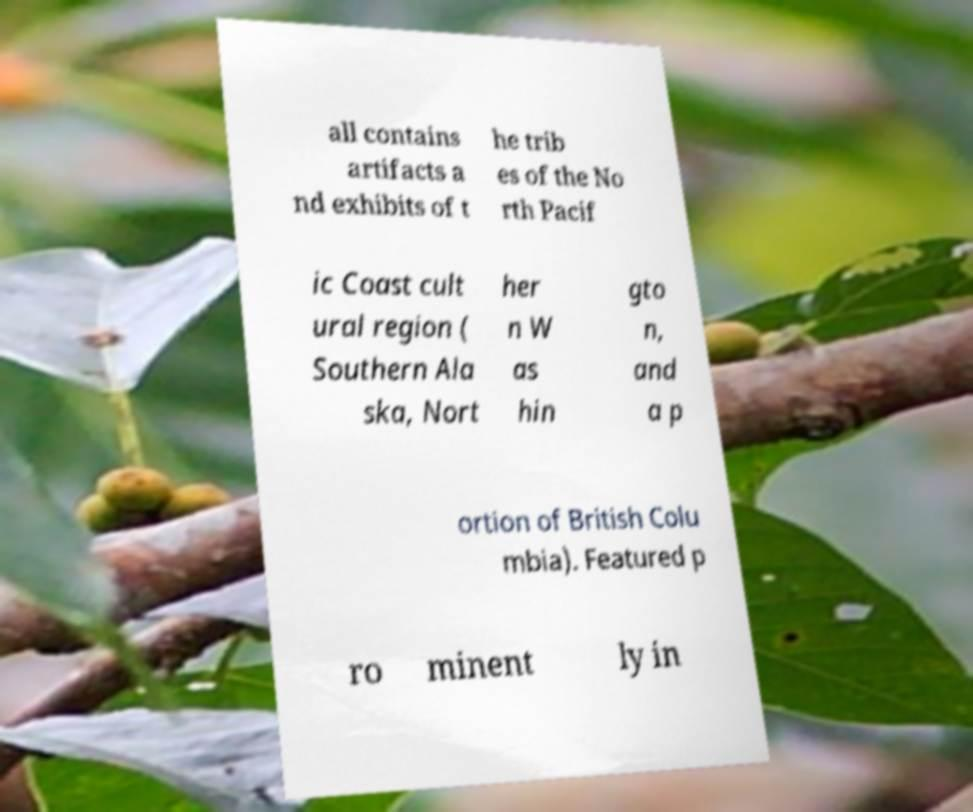Could you assist in decoding the text presented in this image and type it out clearly? all contains artifacts a nd exhibits of t he trib es of the No rth Pacif ic Coast cult ural region ( Southern Ala ska, Nort her n W as hin gto n, and a p ortion of British Colu mbia). Featured p ro minent ly in 